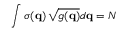<formula> <loc_0><loc_0><loc_500><loc_500>\int \sigma ( q ) \, \sqrt { g ( q ) } d q = N</formula> 